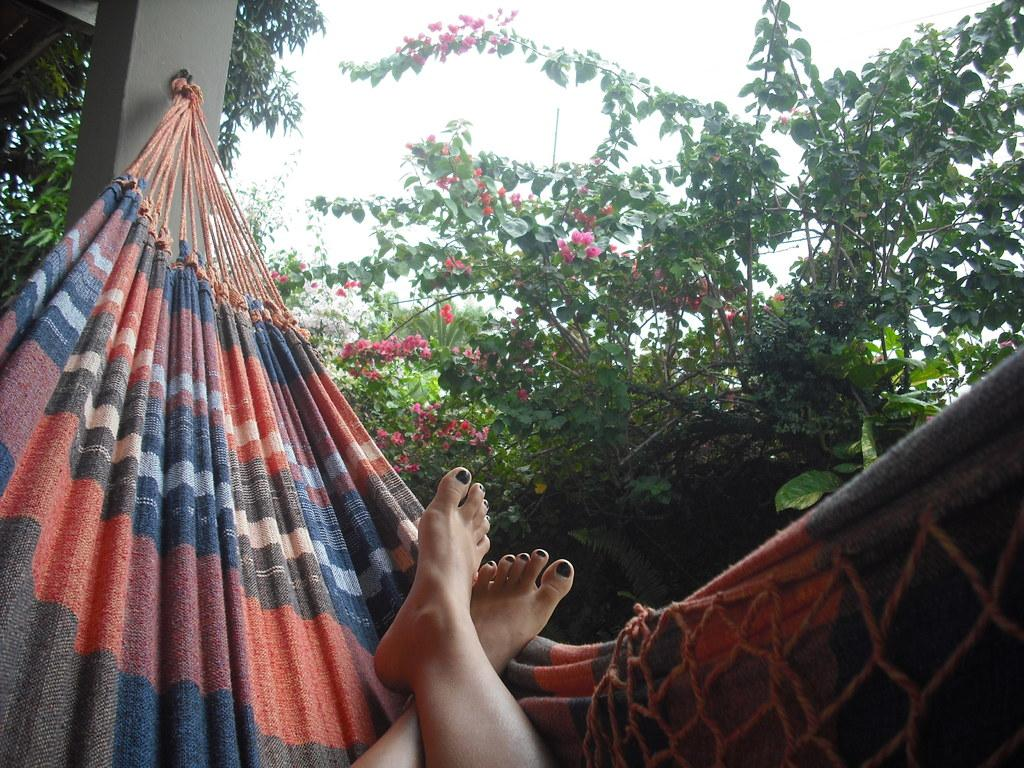What type of vegetation is present in the image? There are trees with flowers in the image. What part of a person can be seen in the image? Human legs are visible in the image. What object is attached to a pillar in the image? There is a cloth attached to a pillar in the image. How would you describe the sky in the image? The sky is cloudy in the image. How many women are present in the image? There is no mention of women in the provided facts, so we cannot determine the number of women in the image. What does the dad in the image say to his child? There is no mention of a dad or a child in the provided facts, so we cannot determine what the dad says in the image. 